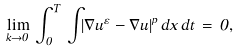<formula> <loc_0><loc_0><loc_500><loc_500>\lim _ { k \rightarrow 0 } \, \int _ { 0 } ^ { T } \, \int _ { \Omega } | \nabla u ^ { \varepsilon } - \nabla u | ^ { p } \, d x \, d t \, = \, 0 ,</formula> 